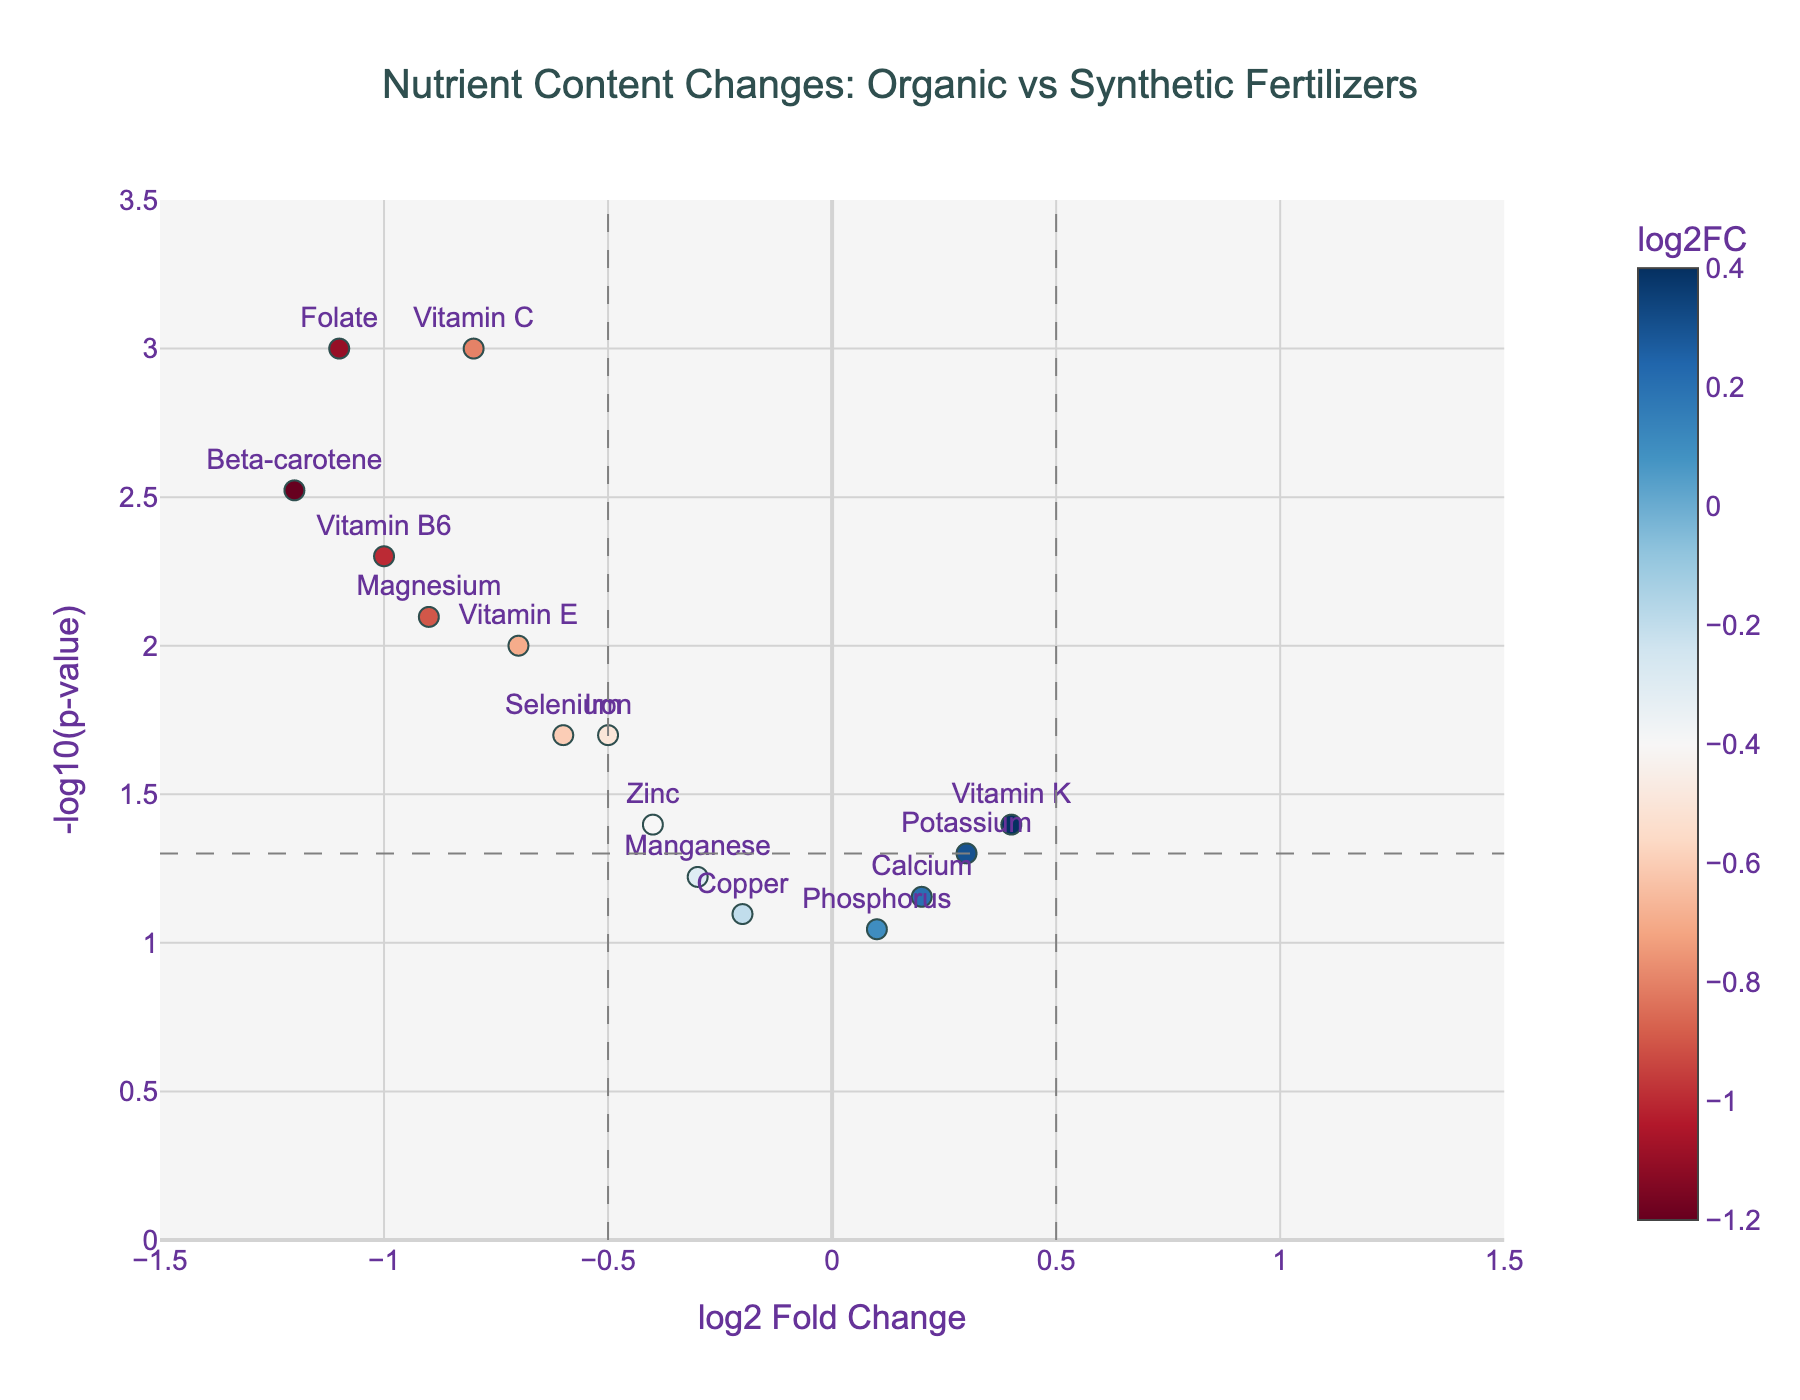What is the nutrient with the highest fold change in the plot? By looking at the x-axis, the nutrient with the highest positive log2 fold change is Vitamin K, at approximately 0.4.
Answer: Vitamin K Which nutrients have a log2 fold change less than -1? Log2 fold change values less than -1 are Beta-carotene, Folate, and Vitamin B6, as they all have log2 fold change values near -1.2, -1.1, and -1.0, respectively.
Answer: Beta-carotene, Folate, Vitamin B6 What p-value threshold is indicated by the dashed horizontal line? The dashed horizontal line corresponds to the -log10(p-value) threshold. The line is drawn at -log10(0.05), which is approximately 1.3.
Answer: 0.05 Which nutrient has the lowest p-value and what is its value? The lowest p-value corresponds to the highest -log10(p-value) value. Vitamin C has the highest position in the y-axis at around 3, indicating a p-value of 0.001.
Answer: Vitamin C, 0.001 How many nutrients have significant changes in their content with p-values below 0.05? Nutrients below the p-value threshold of 0.05 can be identified by the dashed horizontal line. These nutrients are Vitamin C, Beta-carotene, Iron, Magnesium, Zinc, Folate, Vitamin E, Selenium, and Vitamin B6—totaling 9 nutrients.
Answer: 9 Compare the log2 fold change of Iron and Selenium. Which nutrient experienced a greater decrease? To compare, look at the log2 fold change values of Iron and Selenium. Iron has a log2 fold change of -0.5 and Selenium -0.6. Since both values are negative, the nutrient with the more negative value, Selenium, experienced a greater decrease.
Answer: Selenium Which nutrients have not shown statistically significant changes based on the p-value cutoff of 0.05? Nutrients with p-values above 0.05 are above the horizontal dashed line. These are Potassium, Calcium, Phosphorus, Manganese, and Copper.
Answer: Potassium, Calcium, Phosphorus, Manganese, Copper Which nutrients have positive log2 fold changes? Nutrients with log2 fold changes greater than 0 are Vitamin K, Potassium, Calcium, and Phosphorus as their points are to the right of the origin (0 on the x-axis).
Answer: Vitamin K, Potassium, Calcium, Phosphorus In terms of nutrient content change, how does Beta-carotene compare to Vitamin K? Beta-carotene has a log2 fold change of -1.2 and Vitamin K has a log2 fold change of 0.4. So, Beta-carotene has significantly decreased while Vitamin K has a slight increase.
Answer: Beta-carotene decreased, Vitamin K increased 